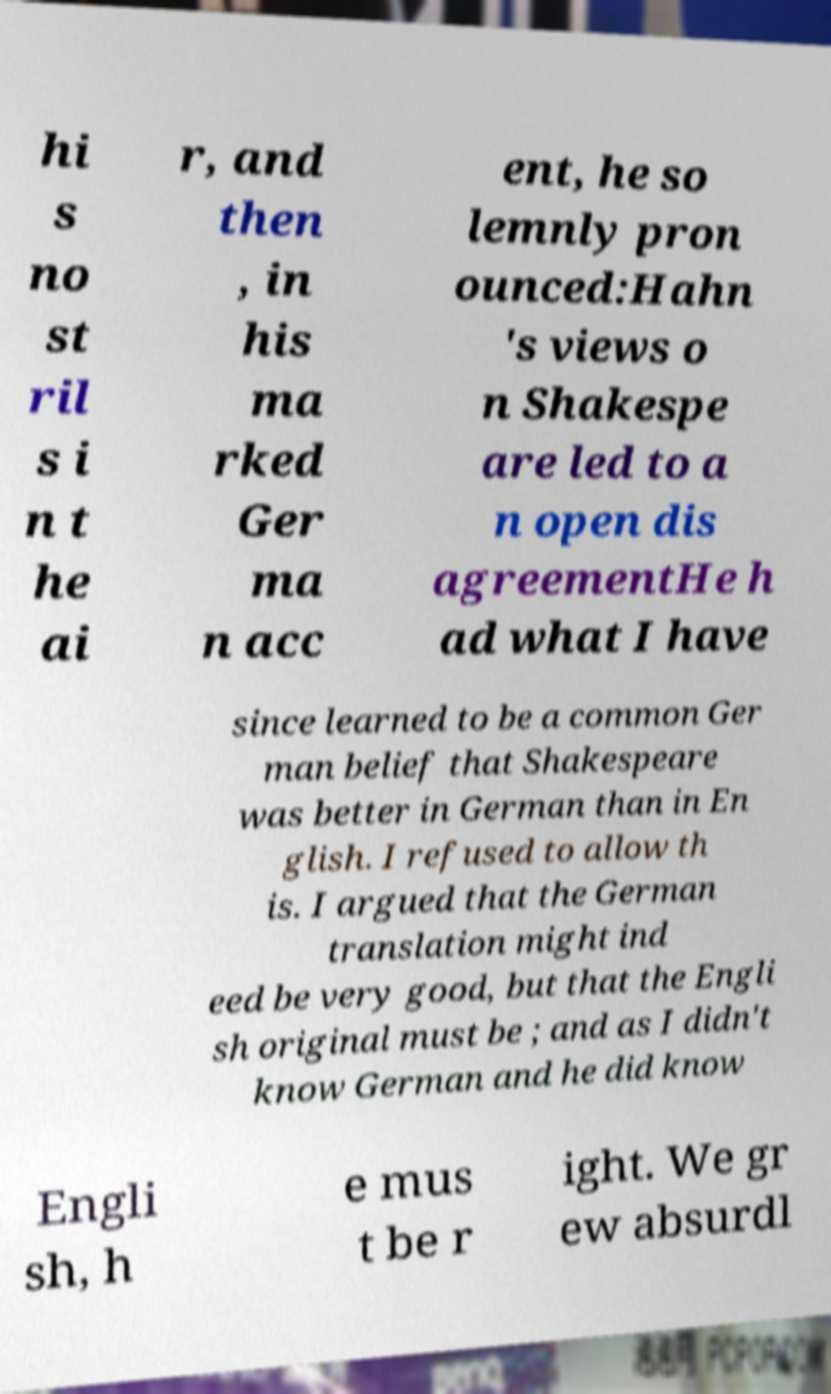Please identify and transcribe the text found in this image. hi s no st ril s i n t he ai r, and then , in his ma rked Ger ma n acc ent, he so lemnly pron ounced:Hahn 's views o n Shakespe are led to a n open dis agreementHe h ad what I have since learned to be a common Ger man belief that Shakespeare was better in German than in En glish. I refused to allow th is. I argued that the German translation might ind eed be very good, but that the Engli sh original must be ; and as I didn't know German and he did know Engli sh, h e mus t be r ight. We gr ew absurdl 